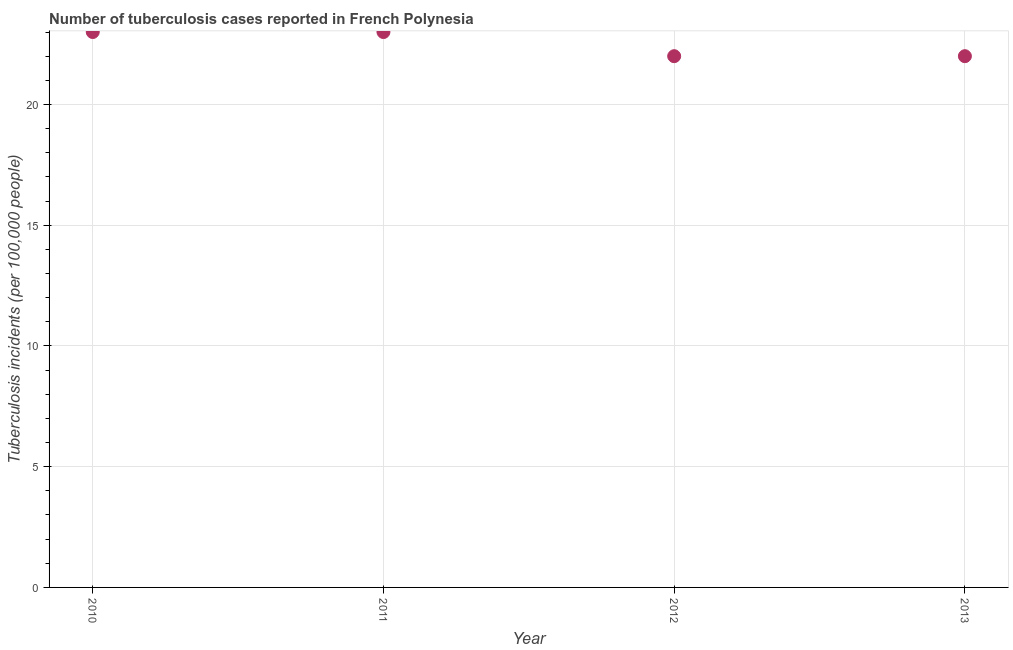What is the number of tuberculosis incidents in 2012?
Give a very brief answer. 22. Across all years, what is the maximum number of tuberculosis incidents?
Provide a succinct answer. 23. Across all years, what is the minimum number of tuberculosis incidents?
Ensure brevity in your answer.  22. In which year was the number of tuberculosis incidents maximum?
Offer a very short reply. 2010. In which year was the number of tuberculosis incidents minimum?
Ensure brevity in your answer.  2012. What is the sum of the number of tuberculosis incidents?
Make the answer very short. 90. What is the difference between the number of tuberculosis incidents in 2010 and 2013?
Keep it short and to the point. 1. What is the average number of tuberculosis incidents per year?
Provide a short and direct response. 22.5. Do a majority of the years between 2012 and 2010 (inclusive) have number of tuberculosis incidents greater than 1 ?
Ensure brevity in your answer.  No. Is the number of tuberculosis incidents in 2010 less than that in 2011?
Offer a terse response. No. What is the difference between the highest and the lowest number of tuberculosis incidents?
Provide a succinct answer. 1. Does the number of tuberculosis incidents monotonically increase over the years?
Your answer should be very brief. No. What is the difference between two consecutive major ticks on the Y-axis?
Give a very brief answer. 5. Are the values on the major ticks of Y-axis written in scientific E-notation?
Your answer should be compact. No. Does the graph contain any zero values?
Your response must be concise. No. Does the graph contain grids?
Provide a short and direct response. Yes. What is the title of the graph?
Ensure brevity in your answer.  Number of tuberculosis cases reported in French Polynesia. What is the label or title of the X-axis?
Ensure brevity in your answer.  Year. What is the label or title of the Y-axis?
Provide a succinct answer. Tuberculosis incidents (per 100,0 people). What is the Tuberculosis incidents (per 100,000 people) in 2013?
Offer a terse response. 22. What is the difference between the Tuberculosis incidents (per 100,000 people) in 2010 and 2011?
Offer a very short reply. 0. What is the difference between the Tuberculosis incidents (per 100,000 people) in 2010 and 2012?
Ensure brevity in your answer.  1. What is the difference between the Tuberculosis incidents (per 100,000 people) in 2010 and 2013?
Your answer should be compact. 1. What is the difference between the Tuberculosis incidents (per 100,000 people) in 2011 and 2012?
Give a very brief answer. 1. What is the difference between the Tuberculosis incidents (per 100,000 people) in 2011 and 2013?
Give a very brief answer. 1. What is the difference between the Tuberculosis incidents (per 100,000 people) in 2012 and 2013?
Offer a terse response. 0. What is the ratio of the Tuberculosis incidents (per 100,000 people) in 2010 to that in 2011?
Make the answer very short. 1. What is the ratio of the Tuberculosis incidents (per 100,000 people) in 2010 to that in 2012?
Provide a short and direct response. 1.04. What is the ratio of the Tuberculosis incidents (per 100,000 people) in 2010 to that in 2013?
Your answer should be very brief. 1.04. What is the ratio of the Tuberculosis incidents (per 100,000 people) in 2011 to that in 2012?
Your answer should be compact. 1.04. What is the ratio of the Tuberculosis incidents (per 100,000 people) in 2011 to that in 2013?
Your answer should be compact. 1.04. What is the ratio of the Tuberculosis incidents (per 100,000 people) in 2012 to that in 2013?
Provide a succinct answer. 1. 